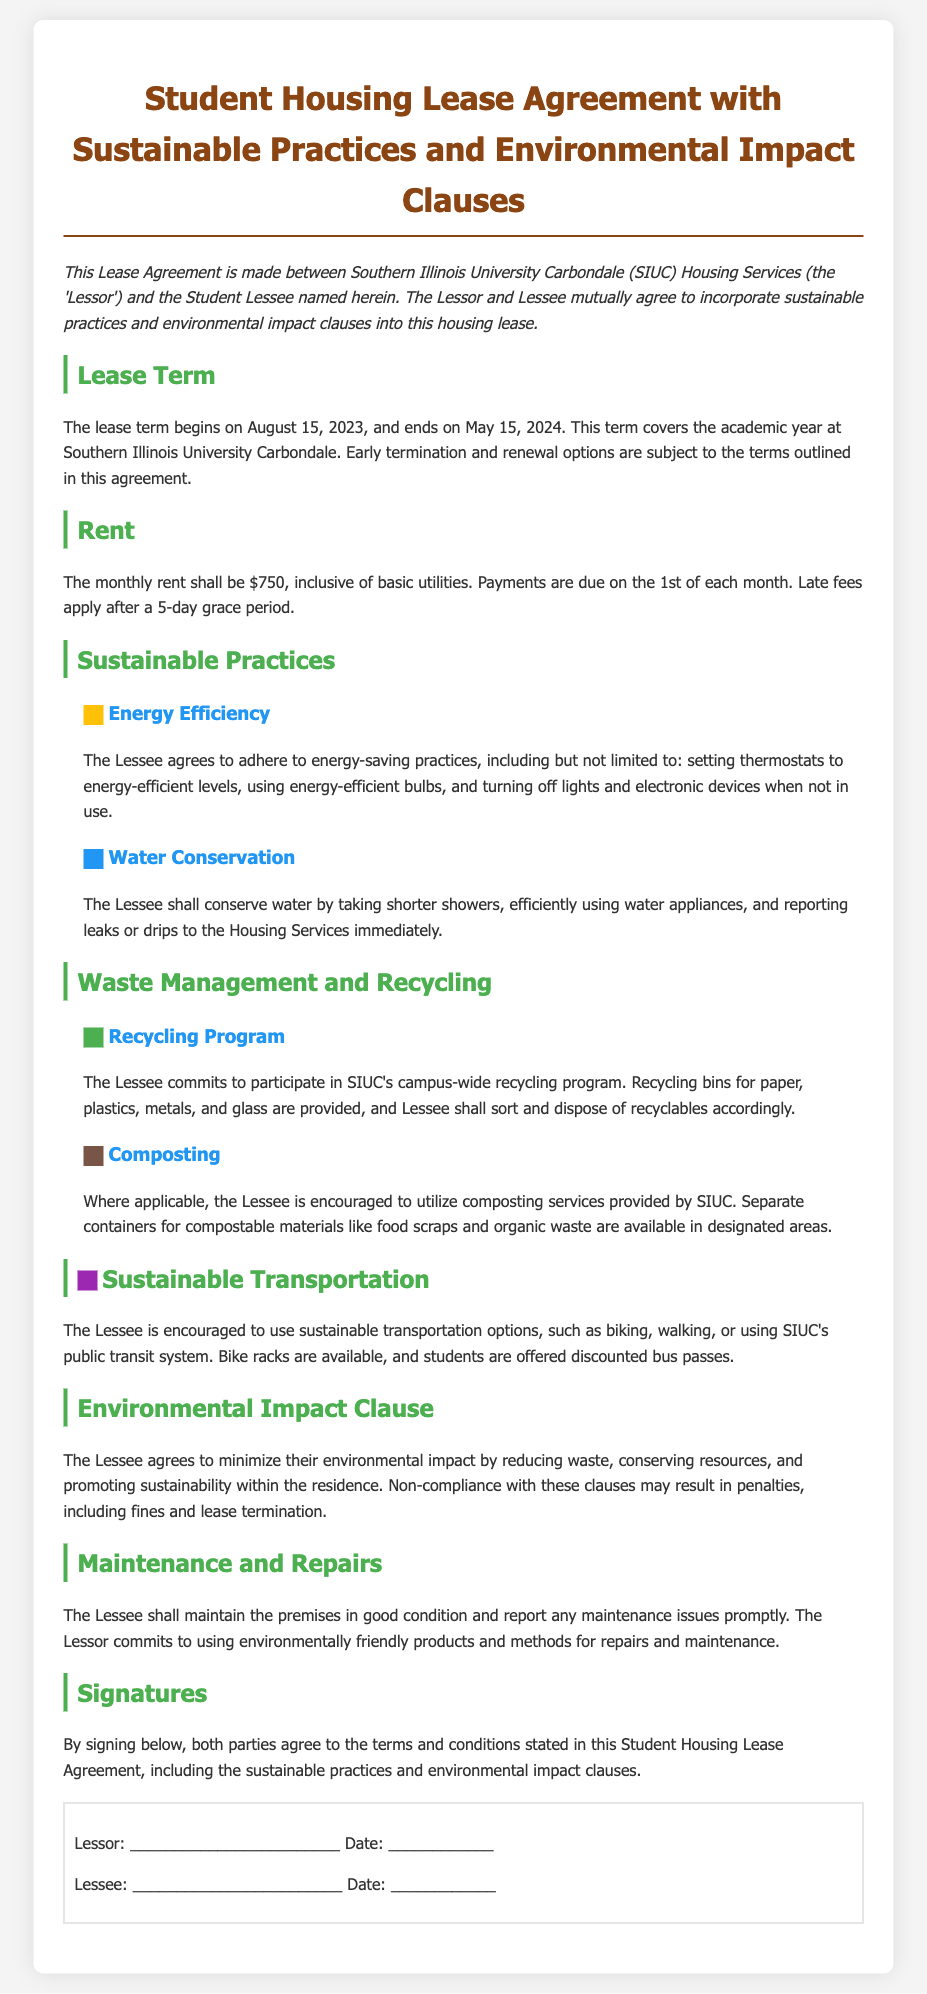What is the lease term start date? The lease term begins on August 15, 2023.
Answer: August 15, 2023 What is the monthly rent amount? The monthly rent is specified as $750.
Answer: $750 What must Lessee do to conserve water? The Lessee shall conserve water by taking shorter showers and reporting leaks or drips.
Answer: Take shorter showers What should the Lessee participate in? The Lessee commits to participate in SIUC's campus-wide recycling program.
Answer: Recycling program What is the penalty for non-compliance with the environmental impact clause? Non-compliance may result in penalties, including fines and lease termination.
Answer: Fines and lease termination What type of products will the Lessor use for maintenance? The Lessor commits to using environmentally friendly products for maintenance.
Answer: Environmentally friendly products Which transportation option is encouraged for the Lessee? The Lessee is encouraged to use sustainable transportation options, such as biking or walking.
Answer: Biking What is included in the monthly rent? The monthly rent is inclusive of basic utilities.
Answer: Basic utilities 